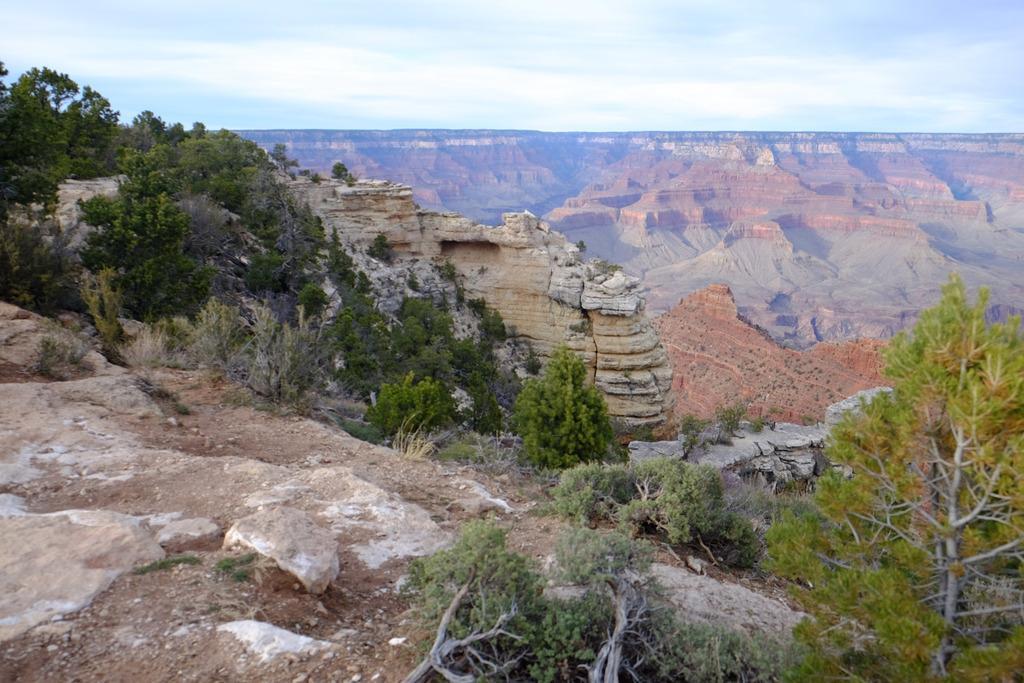Describe this image in one or two sentences. In this image there are mountains, trees, plants, and, and and some rocks. And at the bottom of the image there is sky. 